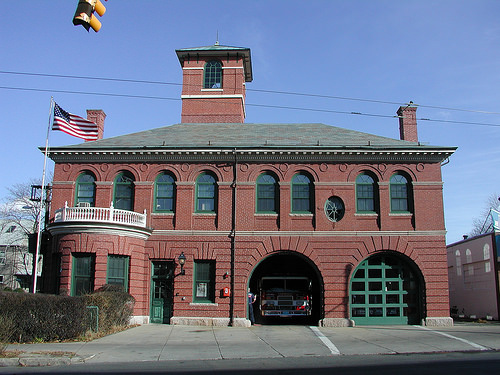<image>
Is the firetruck next to the building? Yes. The firetruck is positioned adjacent to the building, located nearby in the same general area. 